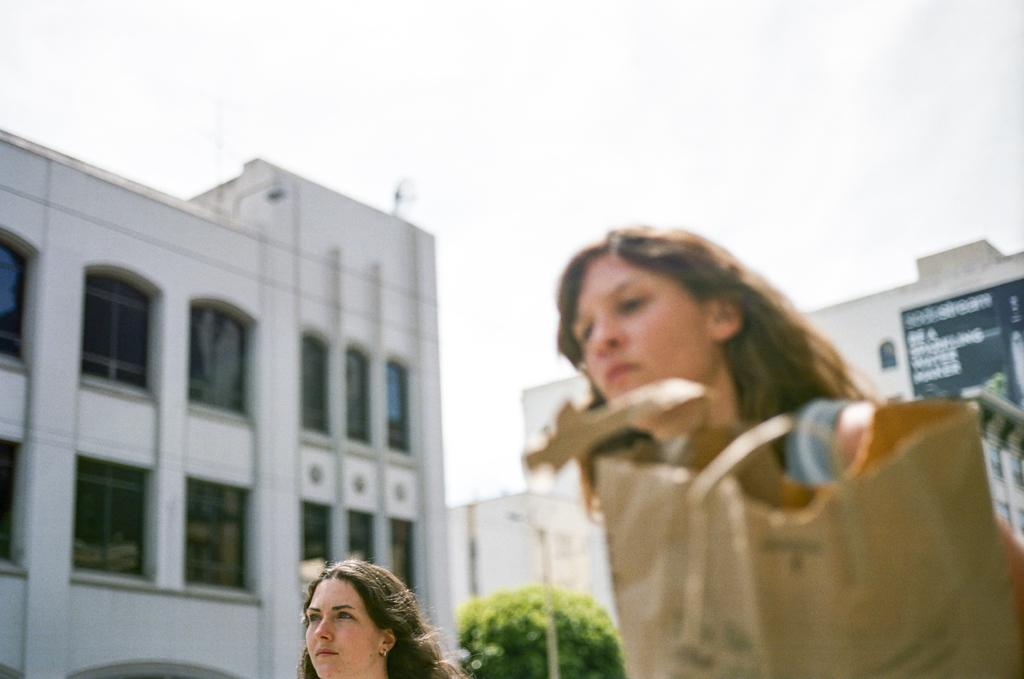How many women are in the image? There are two women in the image. What object can be seen in the image besides the women? There is a bag in the image. What can be seen in the background of the image? There are buildings with windows, a tree, a street pole, and the sky in the background of the image. What is the condition of the sky in the image? The sky appears cloudy in the image. Can you see any grass growing around the tree in the image? There is no grass visible in the image; only the tree, buildings, street pole, and sky are present in the background. 